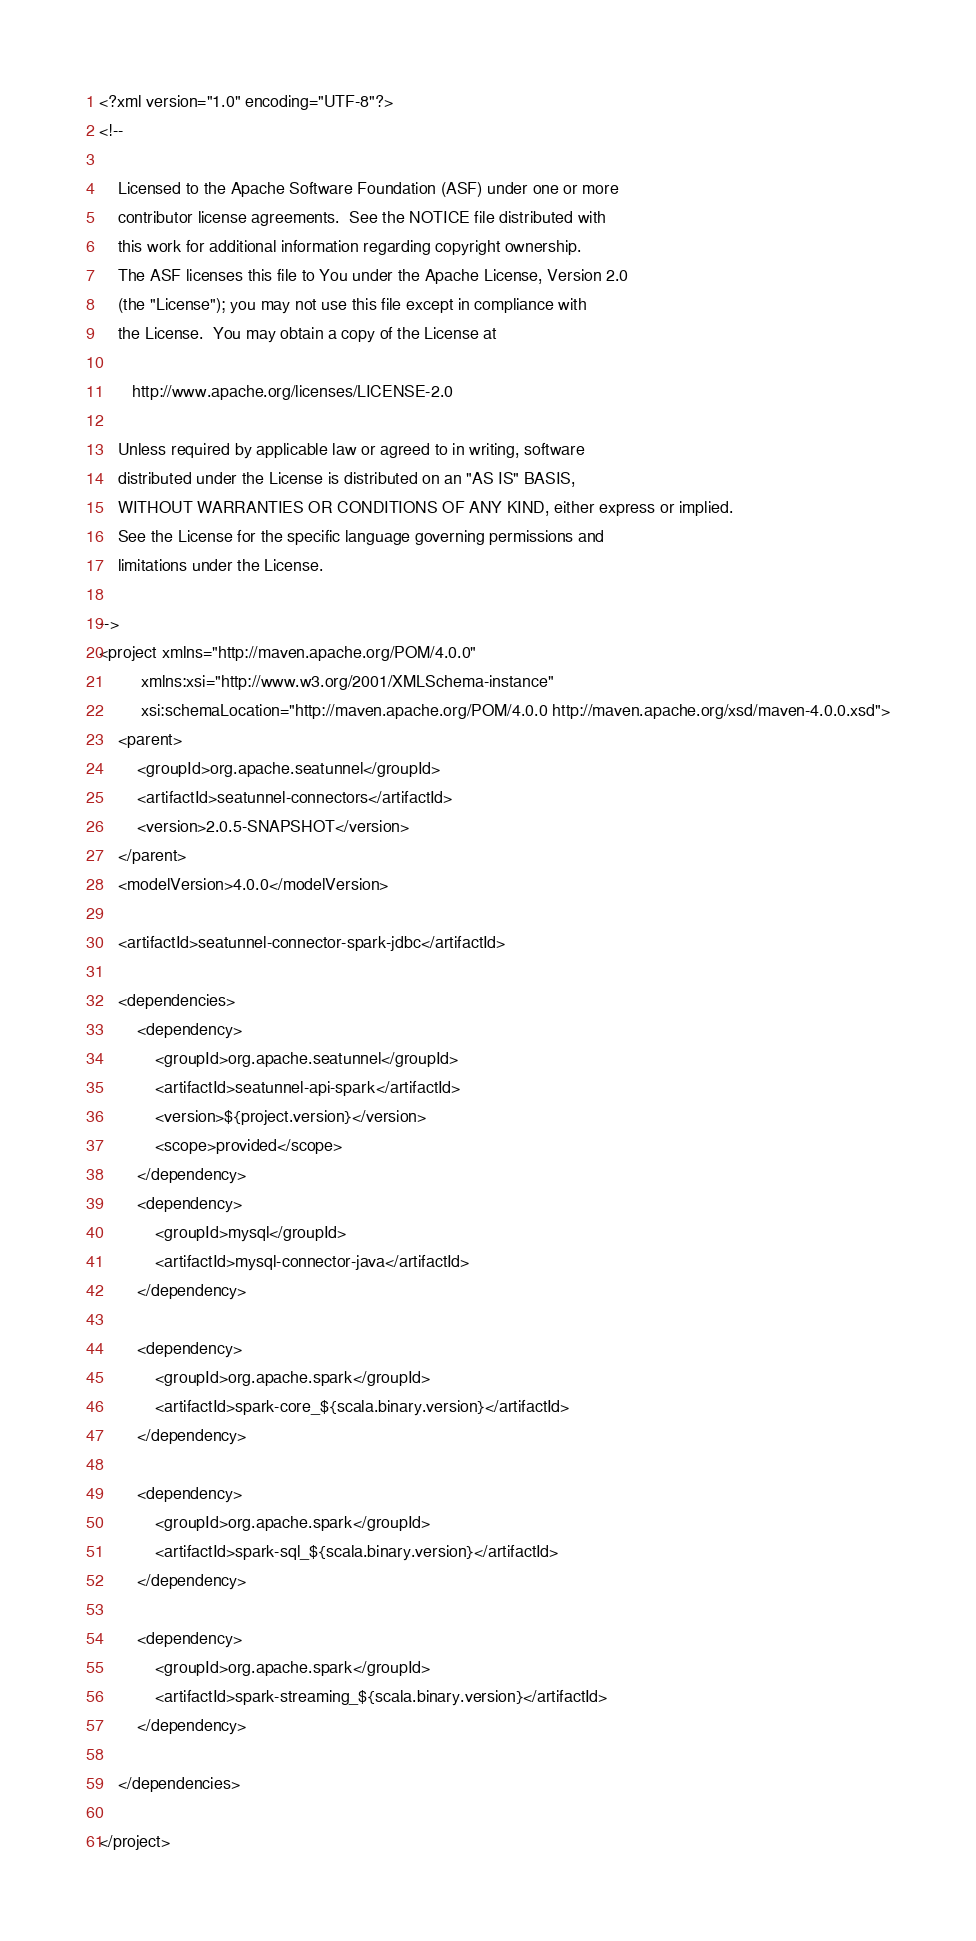Convert code to text. <code><loc_0><loc_0><loc_500><loc_500><_XML_><?xml version="1.0" encoding="UTF-8"?>
<!--

    Licensed to the Apache Software Foundation (ASF) under one or more
    contributor license agreements.  See the NOTICE file distributed with
    this work for additional information regarding copyright ownership.
    The ASF licenses this file to You under the Apache License, Version 2.0
    (the "License"); you may not use this file except in compliance with
    the License.  You may obtain a copy of the License at

       http://www.apache.org/licenses/LICENSE-2.0

    Unless required by applicable law or agreed to in writing, software
    distributed under the License is distributed on an "AS IS" BASIS,
    WITHOUT WARRANTIES OR CONDITIONS OF ANY KIND, either express or implied.
    See the License for the specific language governing permissions and
    limitations under the License.

-->
<project xmlns="http://maven.apache.org/POM/4.0.0"
         xmlns:xsi="http://www.w3.org/2001/XMLSchema-instance"
         xsi:schemaLocation="http://maven.apache.org/POM/4.0.0 http://maven.apache.org/xsd/maven-4.0.0.xsd">
    <parent>
        <groupId>org.apache.seatunnel</groupId>
        <artifactId>seatunnel-connectors</artifactId>
        <version>2.0.5-SNAPSHOT</version>
    </parent>
    <modelVersion>4.0.0</modelVersion>

    <artifactId>seatunnel-connector-spark-jdbc</artifactId>

    <dependencies>
        <dependency>
            <groupId>org.apache.seatunnel</groupId>
            <artifactId>seatunnel-api-spark</artifactId>
            <version>${project.version}</version>
            <scope>provided</scope>
        </dependency>
        <dependency>
            <groupId>mysql</groupId>
            <artifactId>mysql-connector-java</artifactId>
        </dependency>

        <dependency>
            <groupId>org.apache.spark</groupId>
            <artifactId>spark-core_${scala.binary.version}</artifactId>
        </dependency>

        <dependency>
            <groupId>org.apache.spark</groupId>
            <artifactId>spark-sql_${scala.binary.version}</artifactId>
        </dependency>

        <dependency>
            <groupId>org.apache.spark</groupId>
            <artifactId>spark-streaming_${scala.binary.version}</artifactId>
        </dependency>

    </dependencies>

</project></code> 